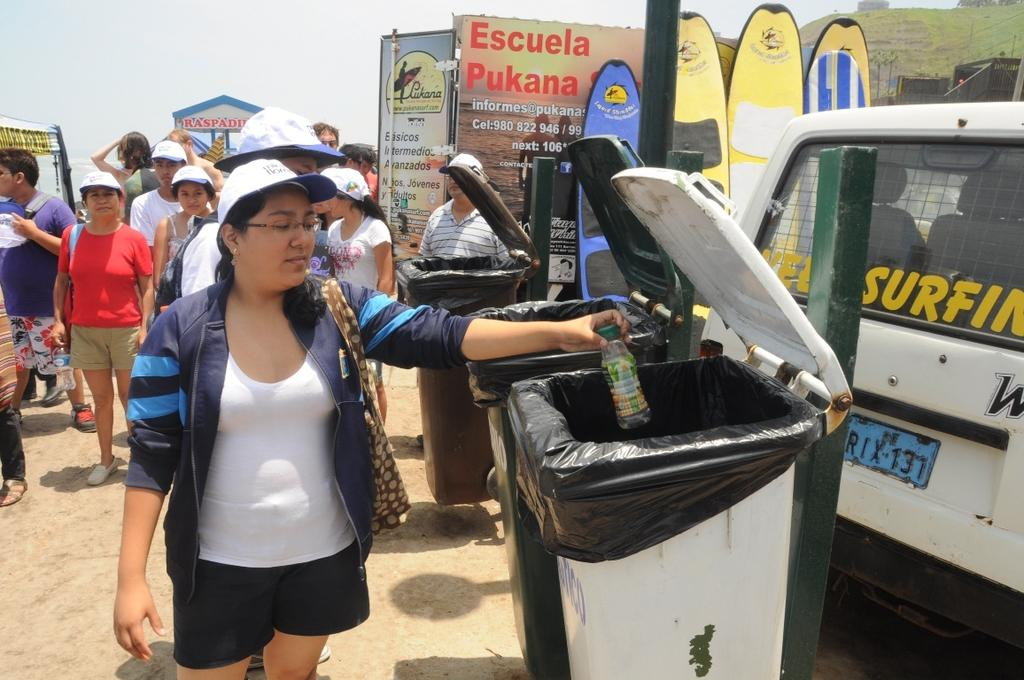<image>
Describe the image concisely. A woman throws away a bottle in front of a banner for Escuela Pukana. 